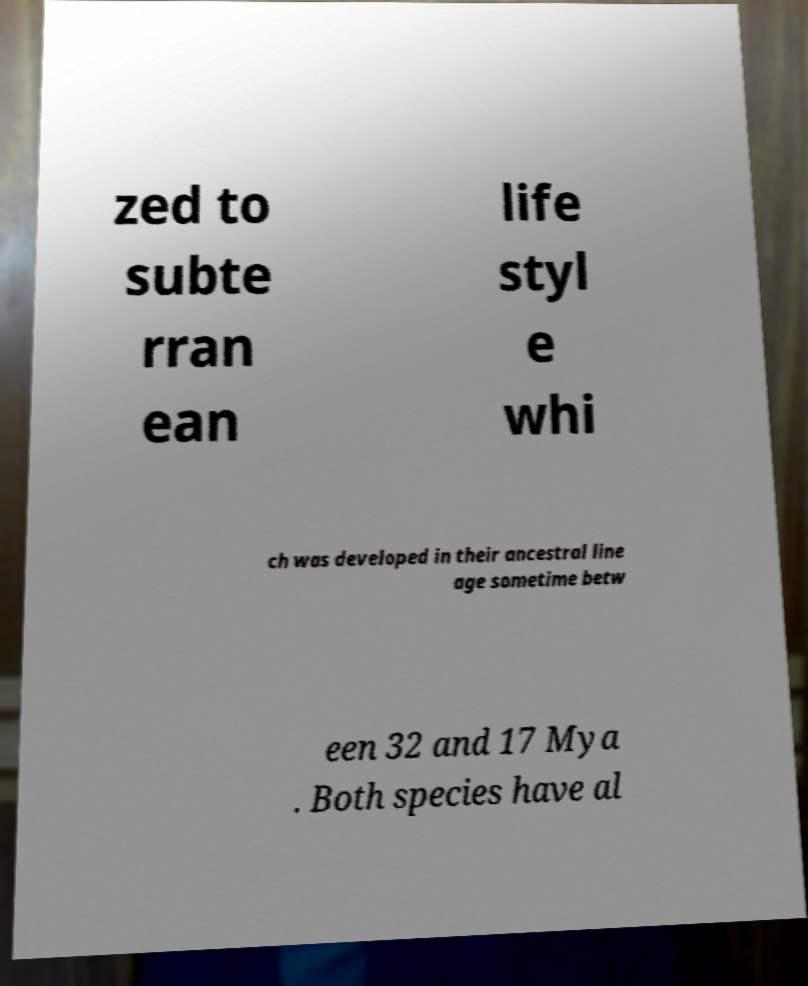What messages or text are displayed in this image? I need them in a readable, typed format. zed to subte rran ean life styl e whi ch was developed in their ancestral line age sometime betw een 32 and 17 Mya . Both species have al 